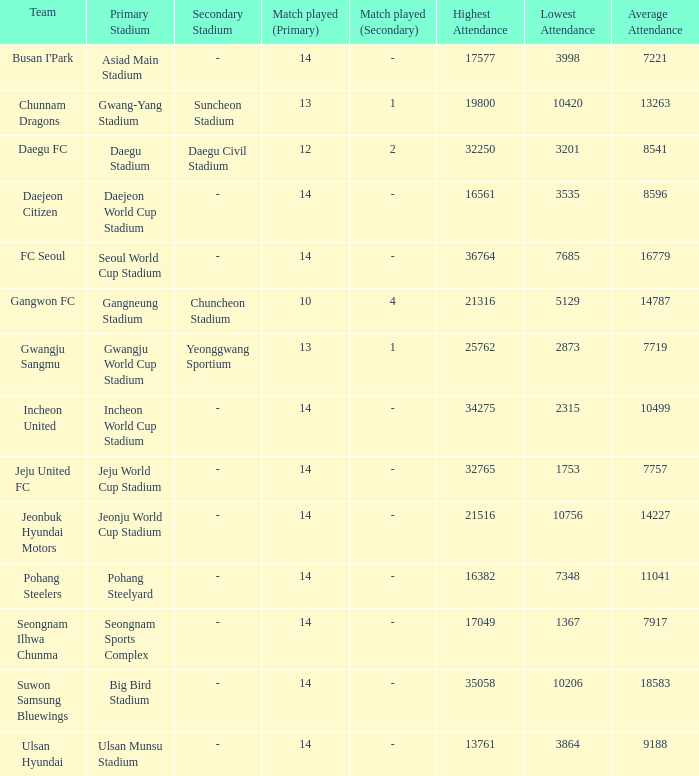Which team has a match played of 10 4? Gangwon FC. 